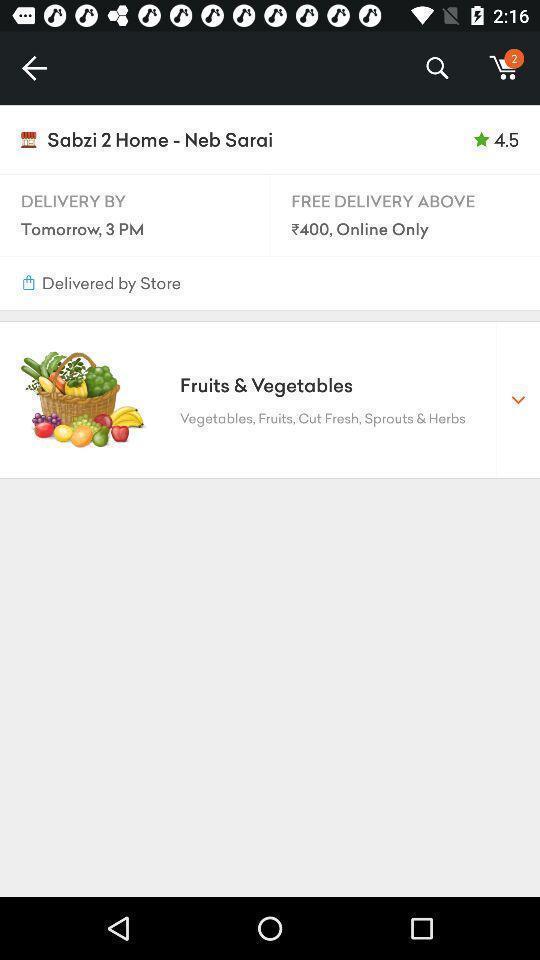Describe this image in words. Screen shows multiple options in a shopping application. 